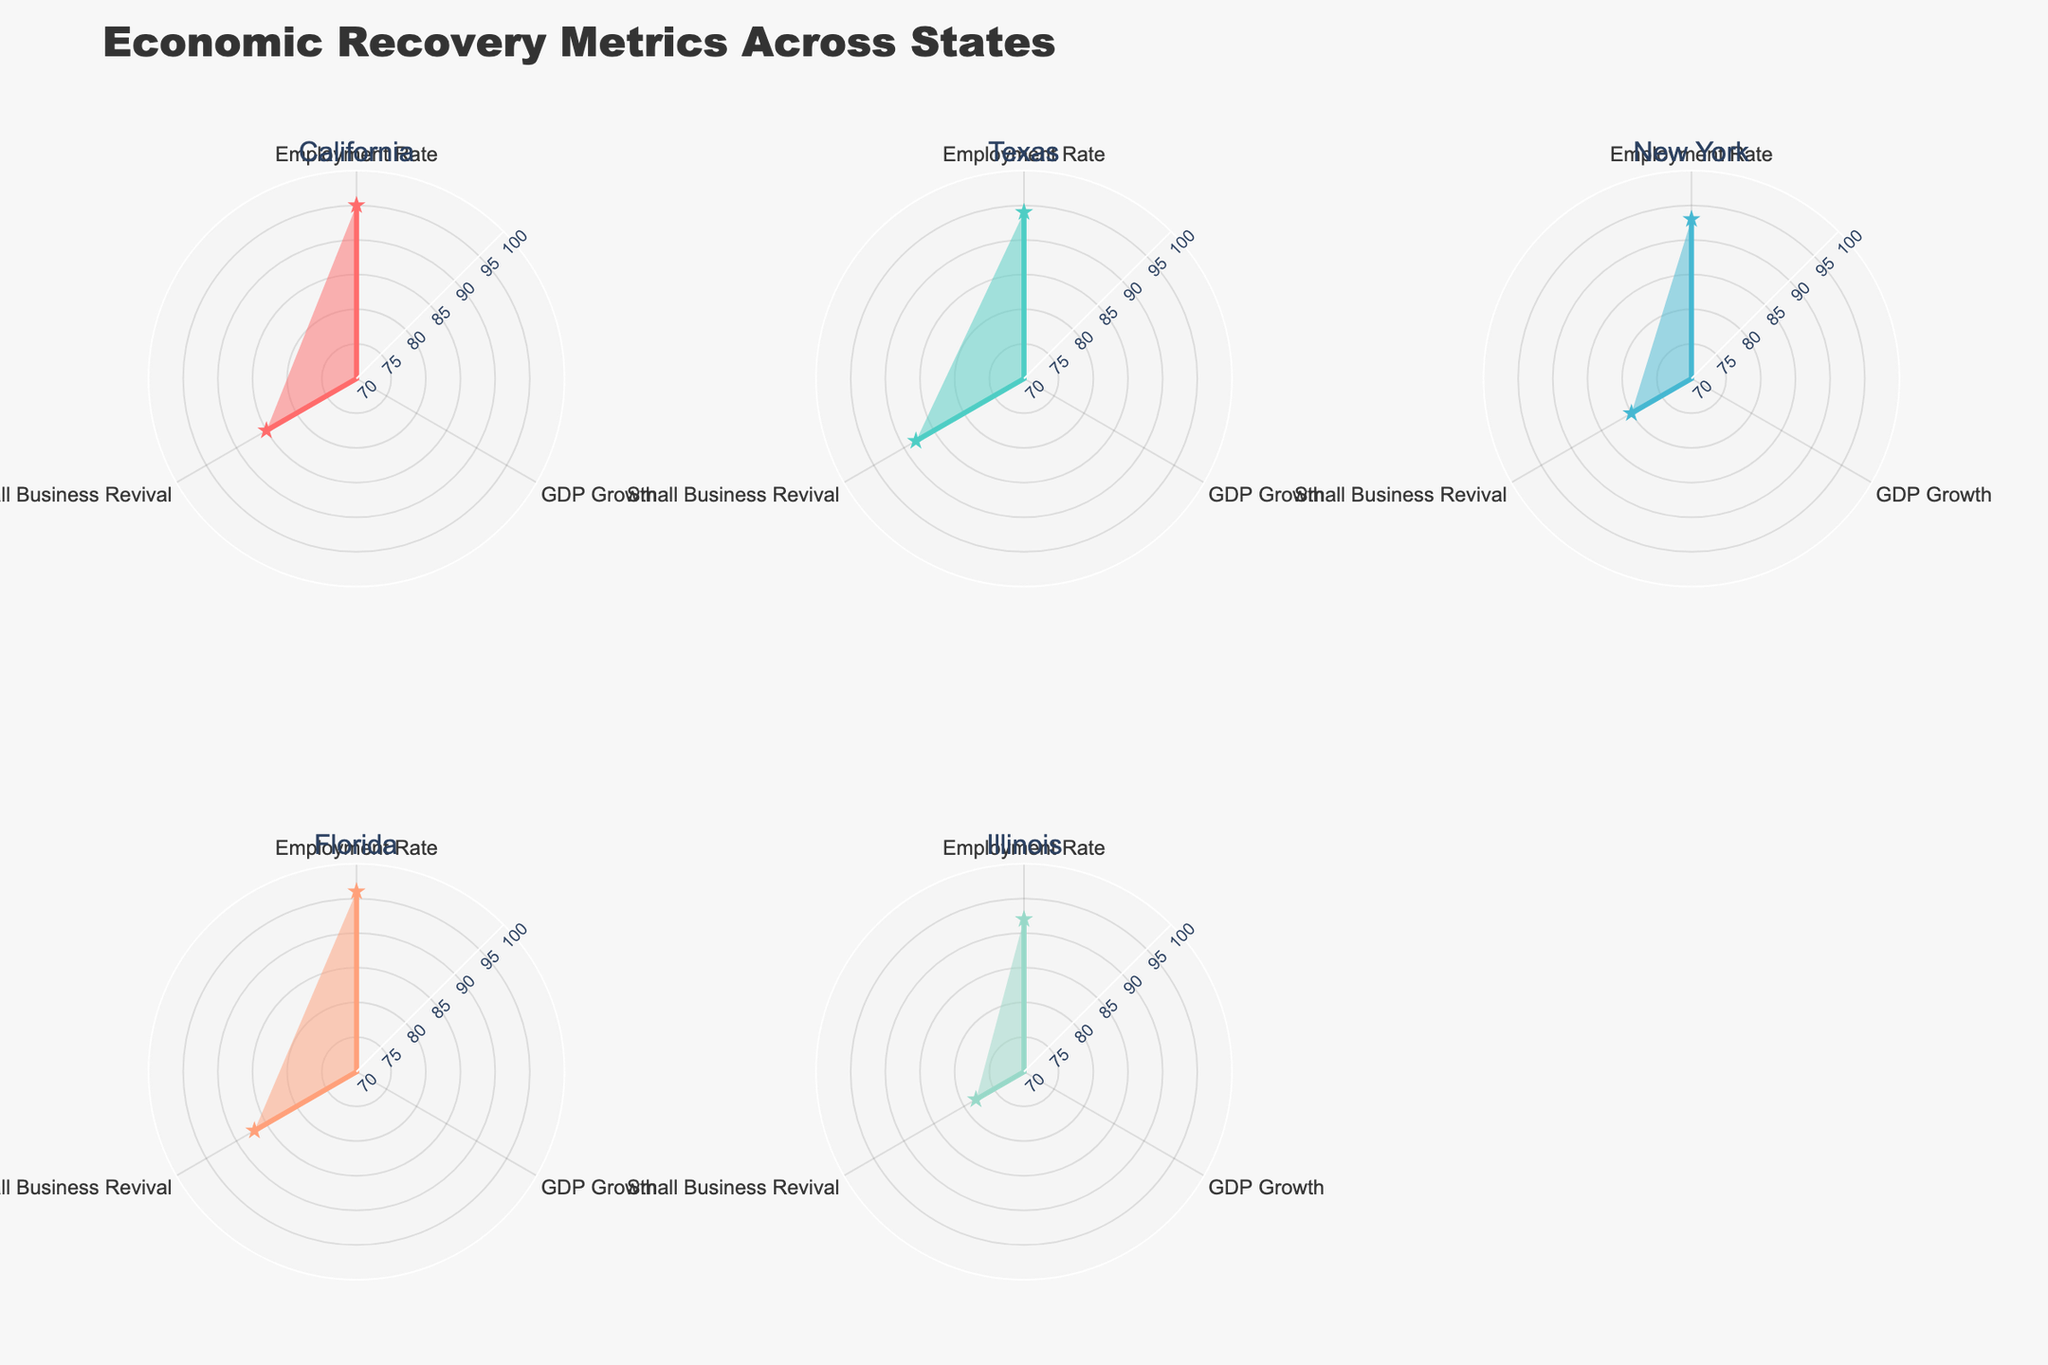Which state has the highest employment rate? The subplot shows the employment rate as one of the metrics. By comparing the values of employment rates across different states, we find that Florida has an employment rate of 96, which is the highest.
Answer: Florida Between Texas and California, which state has a higher GDP growth? The subplot shows GDP growth as one of the metrics. Texas has a GDP growth of 4.1, while California has a GDP growth of 3.5. Texas has a higher GDP growth.
Answer: Texas What is the average small business revival rate among all states? The small business revival rates across the states are 85 (California), 88 (Texas), 80 (New York), 87 (Florida), and 78 (Illinois). Calculating the average: (85 + 88 + 80 + 87 + 78) / 5 = 83.6
Answer: 83.6 Which state shows the smallest GDP growth? By comparing the GDP growth values, Illinois has the smallest GDP growth rate of 2.7.
Answer: Illinois How does the employment rate of New York compare to that of Illinois? The employment rate for New York is 93, and for Illinois, it is 92. New York has a slightly higher employment rate than Illinois.
Answer: New York Which state has the highest small business revival rate? By comparing the small business revival rates, Texas shows the highest value of 88.
Answer: Texas Among the states displayed, which one generally shows the best performance across all three economic recovery metrics? By observing the radar subplots, Florida has the highest employment rate (96) and a relatively high GDP growth (3.8) and small business revival rate (87), indicating the best overall performance.
Answer: Florida What is the difference in employment rates between California and Florida? The employment rate for California is 95, and for Florida, it is 96. The difference is 96 - 95 = 1.
Answer: 1 Is there any state where the employment rate is below 93? By reviewing the employment rates in the subplots, only Illinois has an employment rate of 92, which is below 93.
Answer: Illinois 